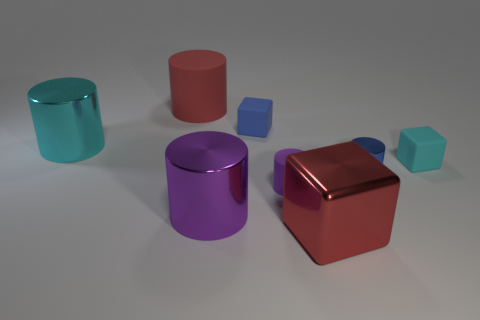What number of rubber cubes have the same color as the large rubber cylinder? There are no rubber cubes that have the same color as the large rubber cylinder in the image. Each object has a unique color. 